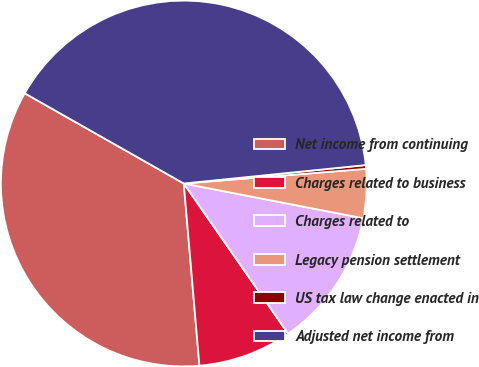Convert chart to OTSL. <chart><loc_0><loc_0><loc_500><loc_500><pie_chart><fcel>Net income from continuing<fcel>Charges related to business<fcel>Charges related to<fcel>Legacy pension settlement<fcel>US tax law change enacted in<fcel>Adjusted net income from<nl><fcel>34.57%<fcel>8.3%<fcel>12.29%<fcel>4.32%<fcel>0.33%<fcel>40.18%<nl></chart> 